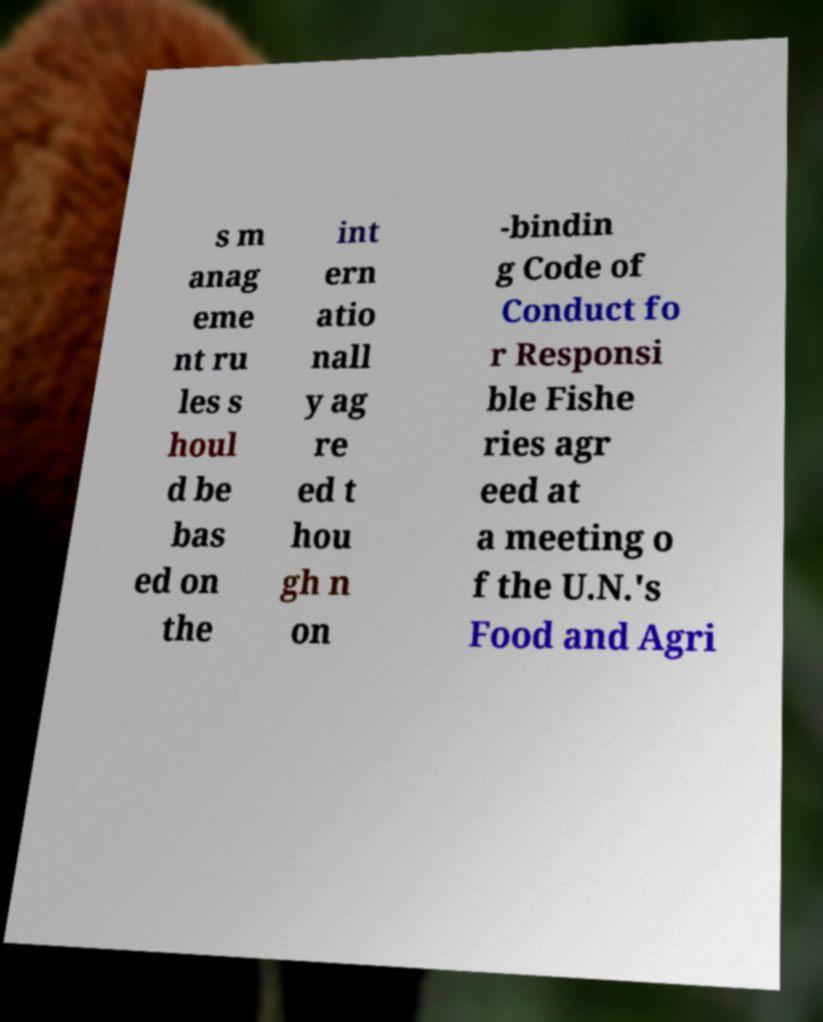Can you accurately transcribe the text from the provided image for me? s m anag eme nt ru les s houl d be bas ed on the int ern atio nall y ag re ed t hou gh n on -bindin g Code of Conduct fo r Responsi ble Fishe ries agr eed at a meeting o f the U.N.'s Food and Agri 